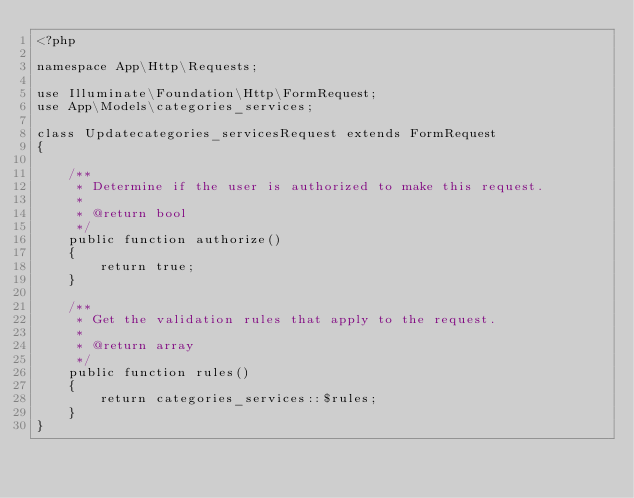Convert code to text. <code><loc_0><loc_0><loc_500><loc_500><_PHP_><?php

namespace App\Http\Requests;

use Illuminate\Foundation\Http\FormRequest;
use App\Models\categories_services;

class Updatecategories_servicesRequest extends FormRequest
{

    /**
     * Determine if the user is authorized to make this request.
     *
     * @return bool
     */
    public function authorize()
    {
        return true;
    }

    /**
     * Get the validation rules that apply to the request.
     *
     * @return array
     */
    public function rules()
    {
        return categories_services::$rules;
    }
}
</code> 